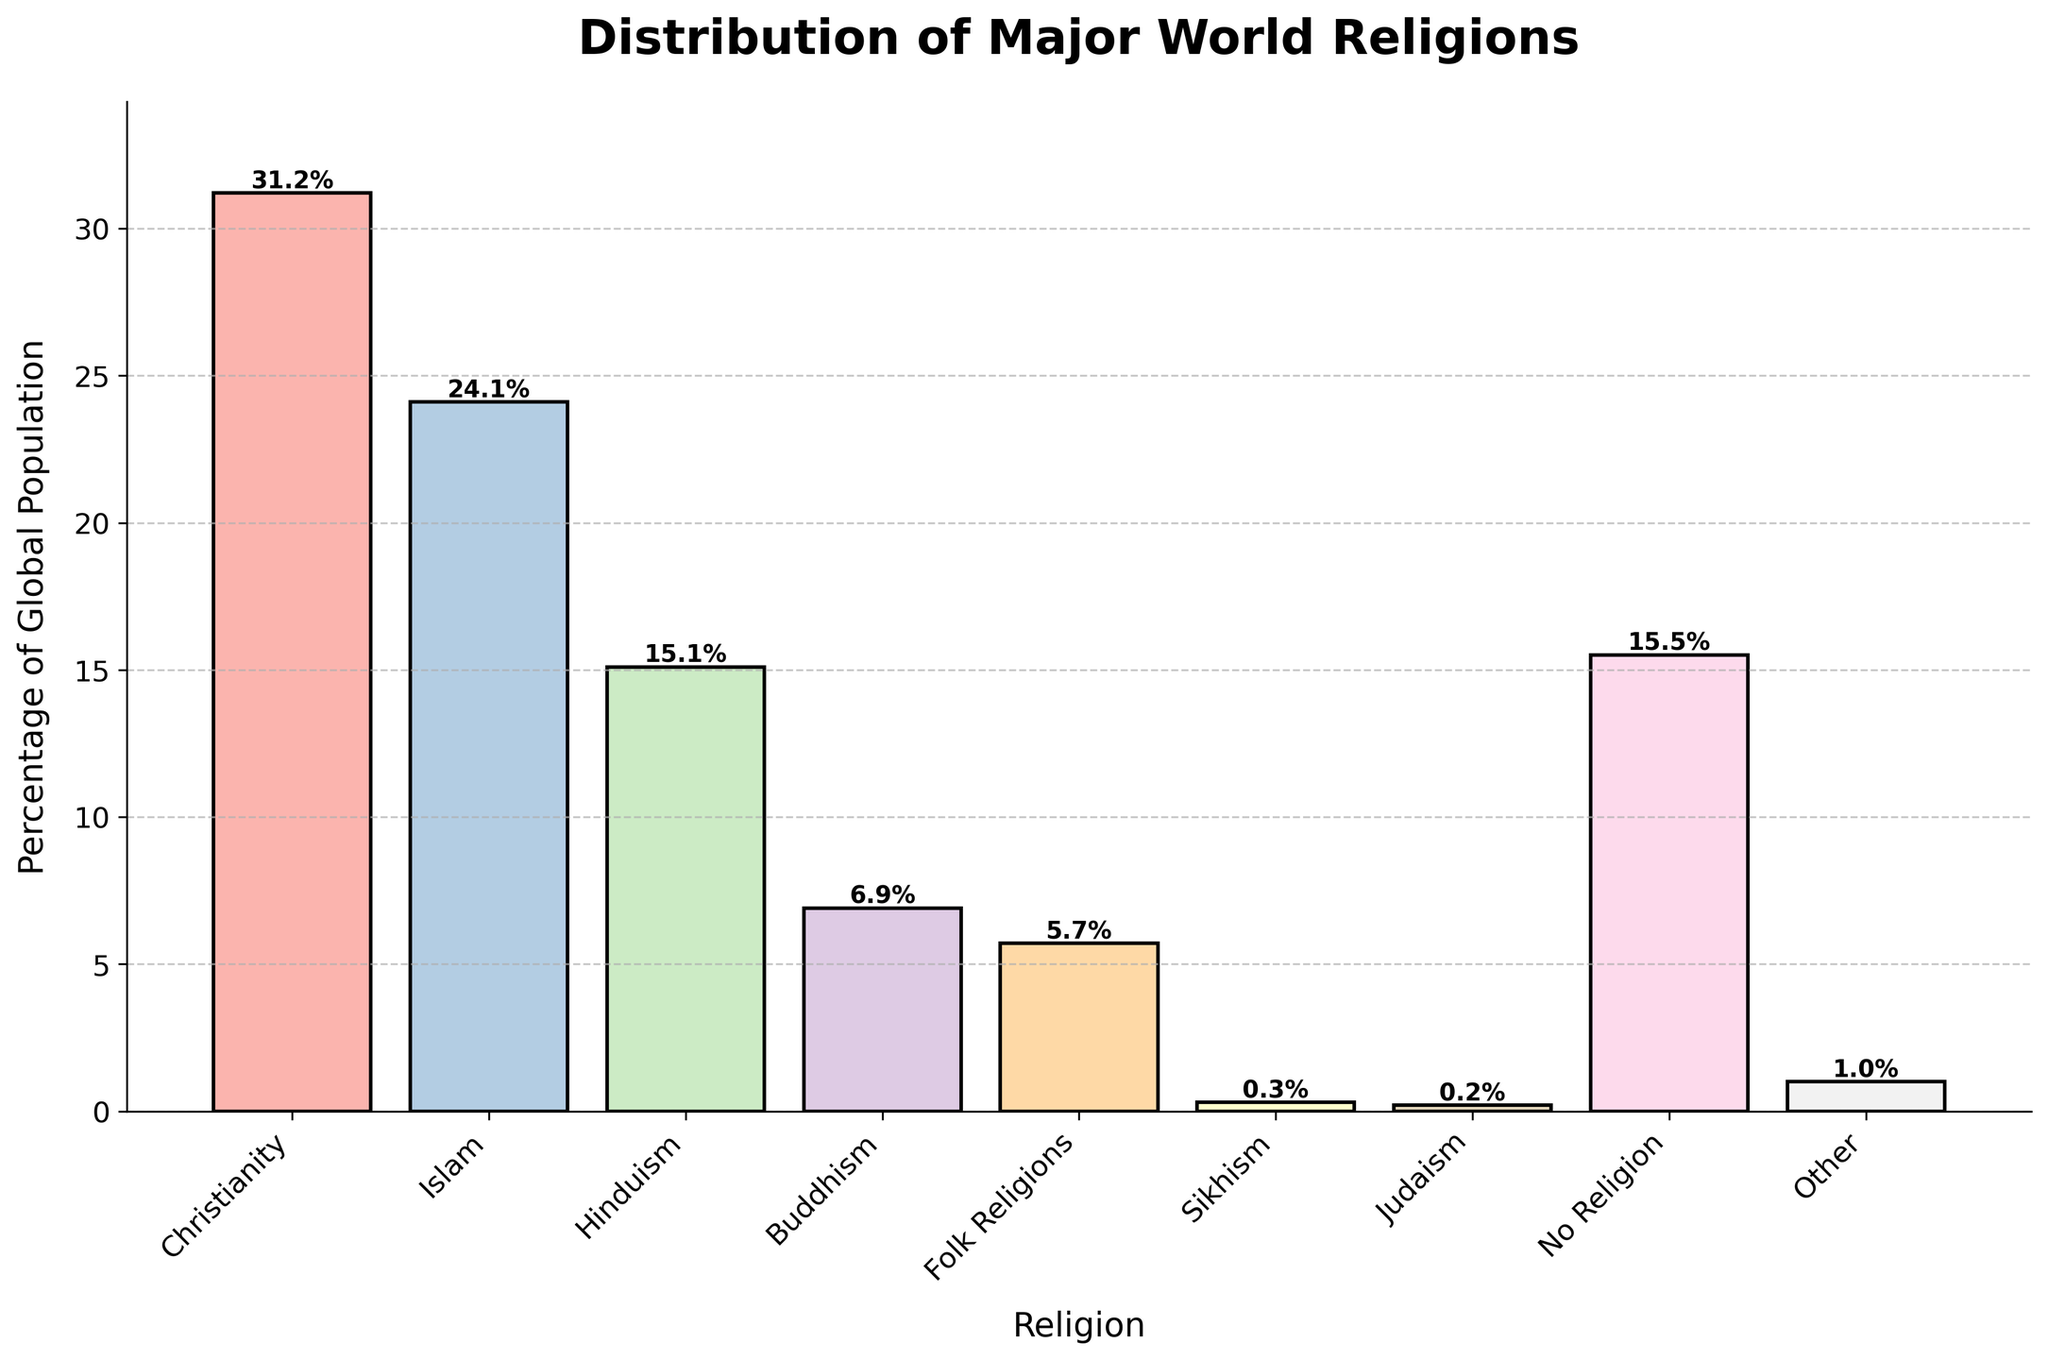Which religion has the highest percentage of the global population? The religion with the highest bar represents the highest percentage. The title of the bar indicates "Christianity" with a height of 31.2%.
Answer: Christianity How much larger is the percentage of Christianity compared to Hinduism? The percentage of Christianity is 31.2%, and Hinduism is 15.1%. Subtract the percentage of Hinduism from Christianity: 31.2% - 15.1% = 16.1%.
Answer: 16.1% Which religions combined have a percentage greater than Islam but less than Christianity? Islam has 24.1%. Adding up Hinduism (15.1%) and Buddhism (6.9%) equals 22.0%, which is greater than Islam but less than Christianity.
Answer: Hinduism and Buddhism What is the sum of the percentages of religions with less than 1% of the global population? Add the percentages of Sikhism (0.3%), Judaism (0.2%), and Other (1.0%): 0.3% + 0.2% + 1.0% = 1.5%.
Answer: 1.5% How does the percentage of people with no religion compare to the percentage of folk religions? The percentage of "No Religion" is 15.5%, and "Folk Religions" is 5.7%. Subtract the percentage of Folk Religions from No Religion: 15.5% - 5.7% = 9.8%.
Answer: 9.8% What is the average percentage of the four smallest religions by global population? The four smallest religions are Sikhism (0.3%), Judaism (0.2%), Other (1.0%), and Folk Religions (5.7%). Adding these gives 0.3% + 0.2% + 1.0% + 5.7% = 7.2%. Dividing by 4 gives 7.2% / 4 = 1.8%.
Answer: 1.8% Which religion has a very light color and a percentage of about 15.1%? The bar representing Hinduism has a very light color and a percentage of 15.1%.
Answer: Hinduism What is the combined percentage of Buddhism and Judaism? The percentage of Buddhism is 6.9% and Judaism is 0.2%. Adding these gives 6.9% + 0.2% = 7.1%.
Answer: 7.1% How many religions have a percentage greater than 10% of the global population? Which are they? Examine the bars to find percentages greater than 10%. Christianity (31.2%), Islam (24.1%), and Hinduism (15.1%) meet this criterion. There are three such religions: Christianity, Islam, and Hinduism.
Answer: Three: Christianity, Islam, and Hinduism 